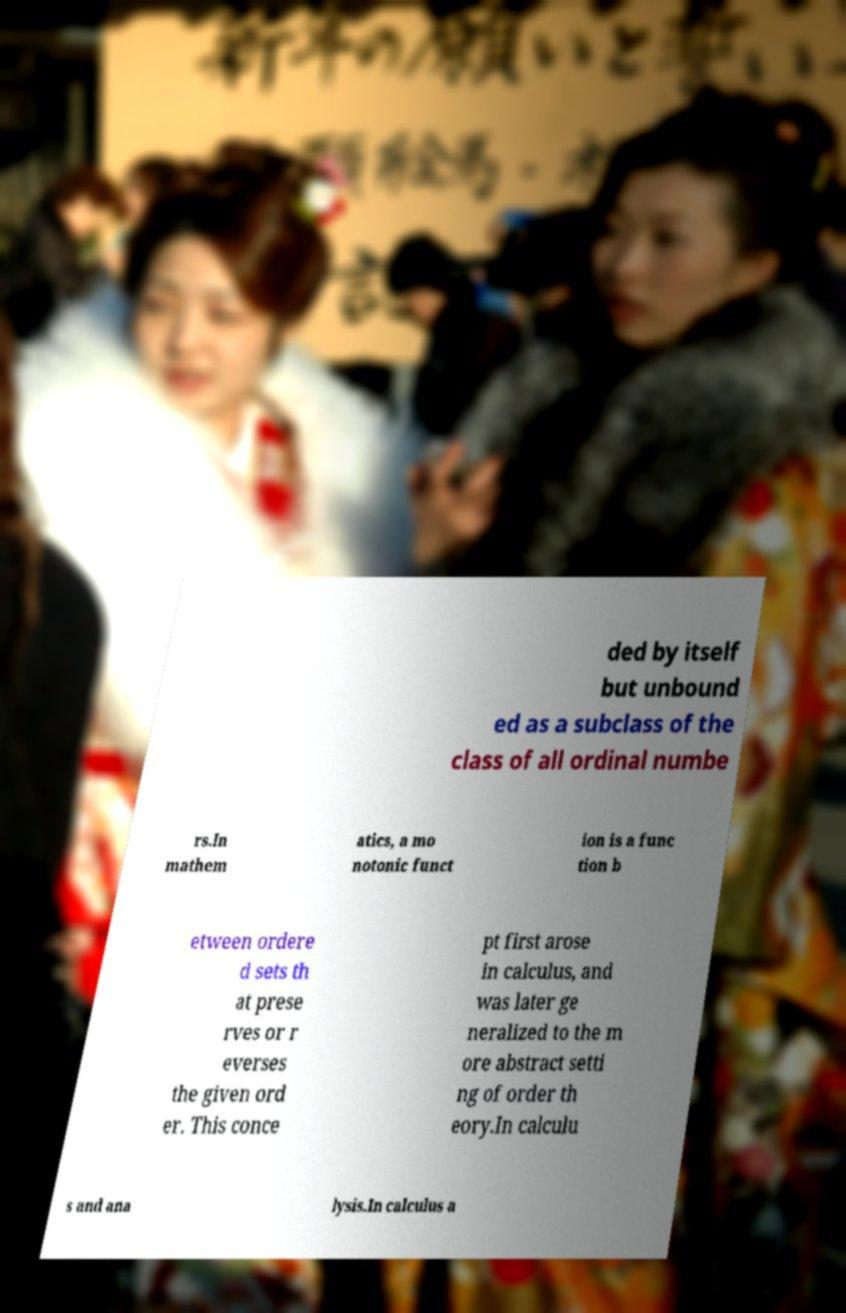Can you accurately transcribe the text from the provided image for me? ded by itself but unbound ed as a subclass of the class of all ordinal numbe rs.In mathem atics, a mo notonic funct ion is a func tion b etween ordere d sets th at prese rves or r everses the given ord er. This conce pt first arose in calculus, and was later ge neralized to the m ore abstract setti ng of order th eory.In calculu s and ana lysis.In calculus a 